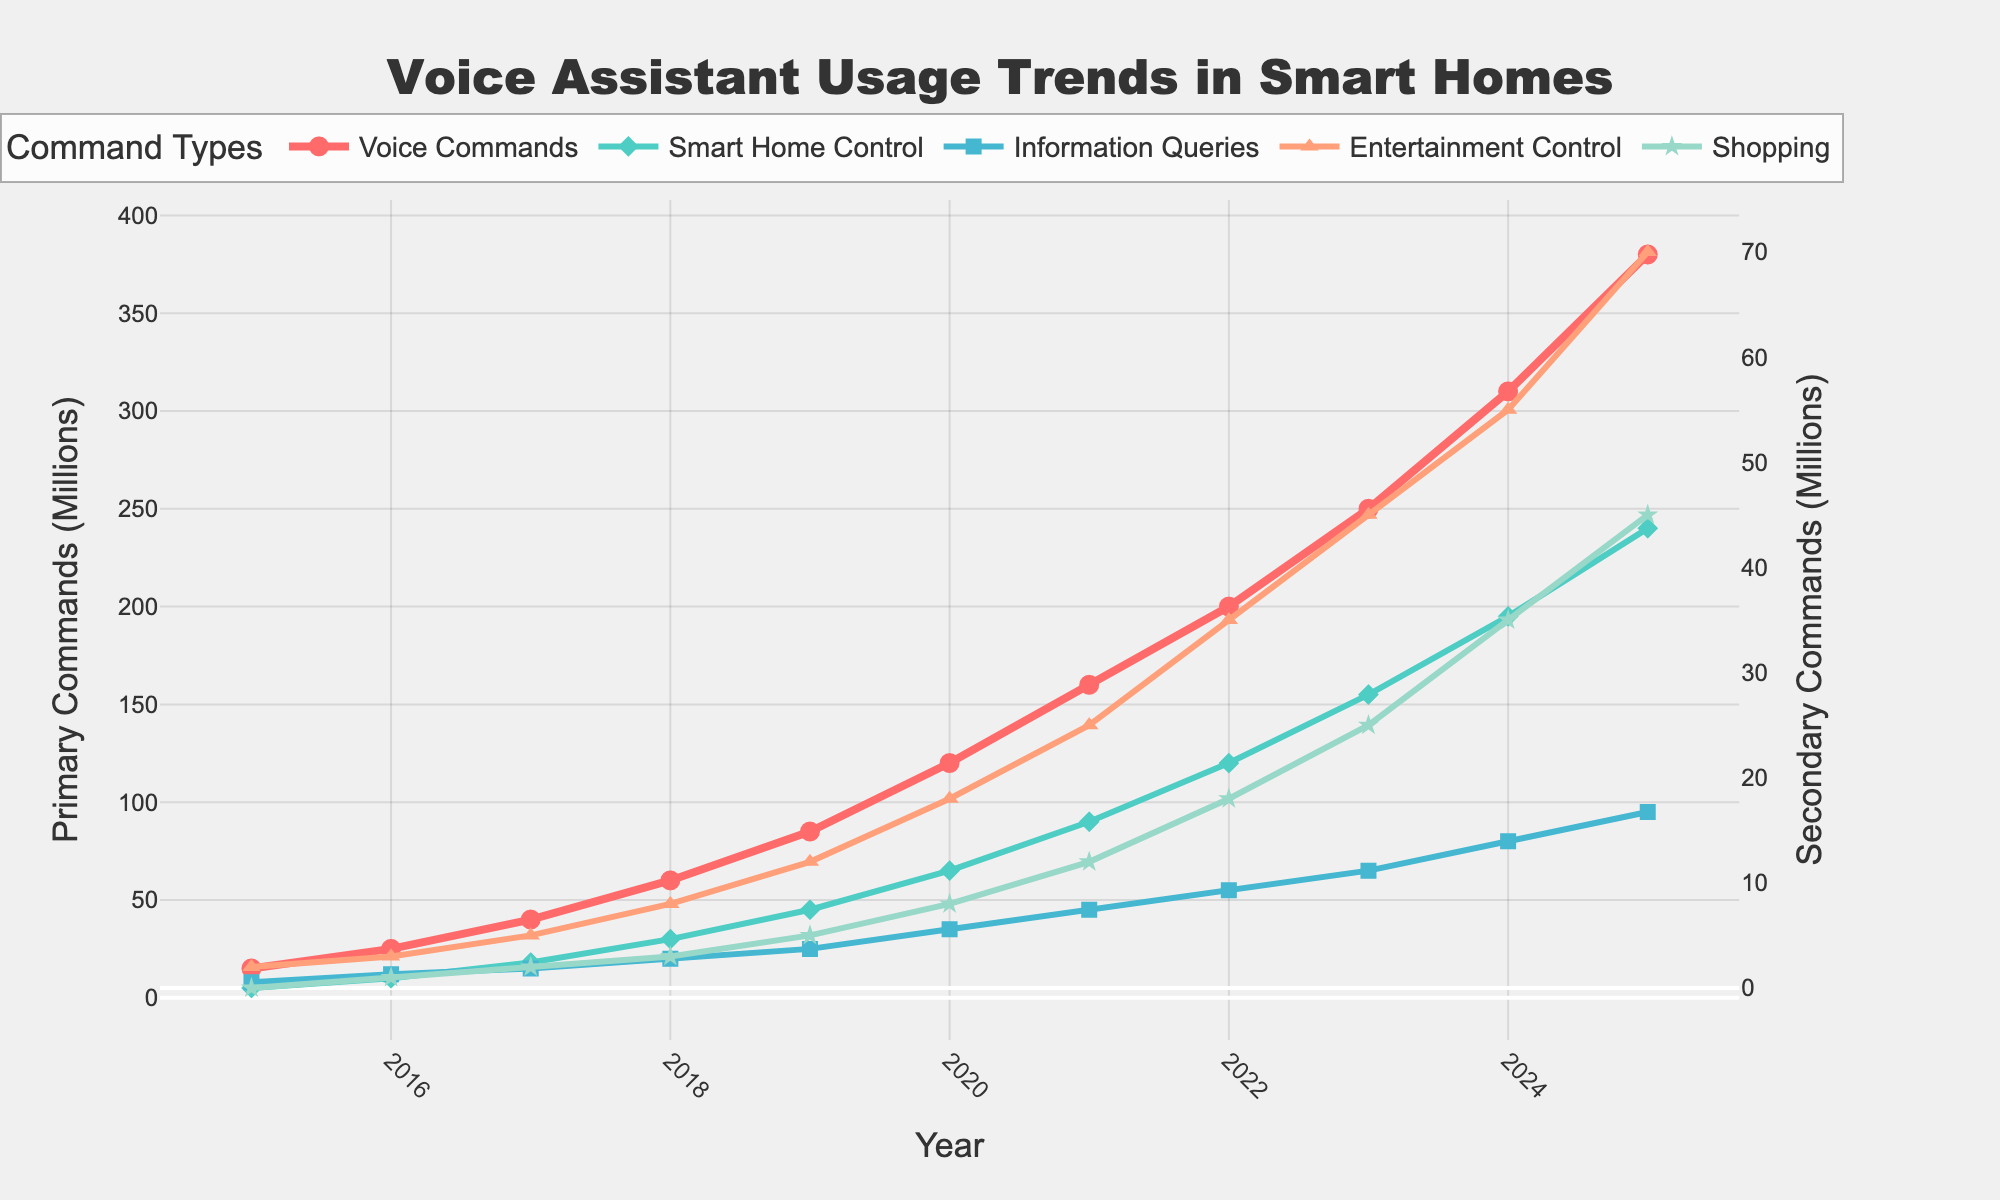How much did the total number of Voice Commands increase from 2015 to 2025? In 2015, the number of Voice Commands was 15 million, and in 2025 it was 380 million. The increase is calculated by subtracting the 2015 value from the 2025 value: 380 - 15 = 365 million.
Answer: 365 million Which command type showed the most significant growth over the period? To determine which command type showed the most significant growth, compare the differences in values from 2015 to 2025 for each command type. "Voice Commands" grew from 15 million to 380 million, which is a difference of 365 million, making it the largest growth.
Answer: Voice Commands What is the trend of Information Queries from 2015 to 2025? Information Queries showed a consistent increase from 8 million in 2015 to 95 million in 2025. The trend is upward.
Answer: Upward For which year did Voice Commands surpass Smart Home Control by at least 50 million? By observing the trend lines, we see that in 2020, Voice Commands reached 120 million and Smart Home Control was at 65 million, making the difference 55 million. Therefore, 2020 is the first year Voice Commands surpass Smart Home Control by at least 50 million.
Answer: 2020 What can be inferred about the growth rate of Shopping commands from 2015 to 2025? Shopping commands started at zero in 2015 and reached 45 million in 2025. This indicates introduction and steady increase over the years as new functionalities were added and users adopted them. The growth rate, while not as steep as some others, shows a consistent upward trend.
Answer: Consistent upward trend Which year shows the highest increase rate in Entertainment Control commands compared to the previous year? To find the highest increase rate year-on-year, we compare each year's value with the previous year's. The largest jump for Entertainment Control is from 2023 to 2024, where it increased from 45 million to 55 million (+10 million).
Answer: 2024 How does the growth rate of Smart Home Control compare to Information Queries from 2015 to 2025? We compare the increase from 2015 to 2025: Smart Home Control grew from 5 million to 240 million (235 million increase) whereas Information Queries grew from 8 million to 95 million (87 million increase). The growth rate of Smart Home Control is therefore higher.
Answer: Higher for Smart Home Control Between which two consecutive years did Voice Commands see its largest increase? By observing the differences year-on-year, the largest increase for Voice Commands occurred between 2023 (250 million) and 2024 (310 million), which is an increase of 60 million.
Answer: 2023-2024 If the trends continue, what might be predicted about the Shopping command usage in the next year? Given the steady upward trend and the increasing increments, it is reasonable to predict that Shopping commands will likely see a further increase. Extrapolating the trend line could suggest usage may exceed 45 million easily.
Answer: Increase expected 